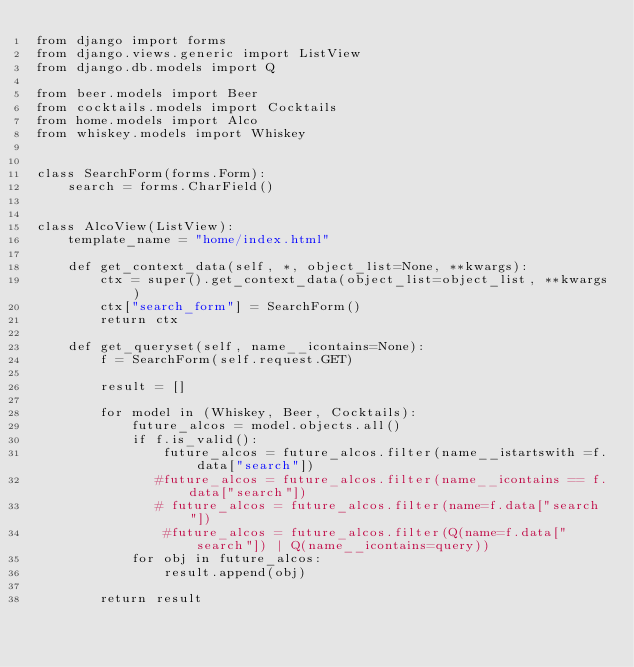Convert code to text. <code><loc_0><loc_0><loc_500><loc_500><_Python_>from django import forms
from django.views.generic import ListView
from django.db.models import Q

from beer.models import Beer
from cocktails.models import Cocktails
from home.models import Alco
from whiskey.models import Whiskey


class SearchForm(forms.Form):
    search = forms.CharField()


class AlcoView(ListView):
    template_name = "home/index.html"

    def get_context_data(self, *, object_list=None, **kwargs):
        ctx = super().get_context_data(object_list=object_list, **kwargs)
        ctx["search_form"] = SearchForm()
        return ctx

    def get_queryset(self, name__icontains=None):
        f = SearchForm(self.request.GET)

        result = []

        for model in (Whiskey, Beer, Cocktails):
            future_alcos = model.objects.all()
            if f.is_valid():
                future_alcos = future_alcos.filter(name__istartswith =f.data["search"])
               #future_alcos = future_alcos.filter(name__icontains == f.data["search"])
               # future_alcos = future_alcos.filter(name=f.data["search"])
                #future_alcos = future_alcos.filter(Q(name=f.data["search"]) | Q(name__icontains=query))
            for obj in future_alcos:
                result.append(obj)

        return result
</code> 